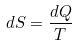Convert formula to latex. <formula><loc_0><loc_0><loc_500><loc_500>d S = \frac { d Q } { T }</formula> 